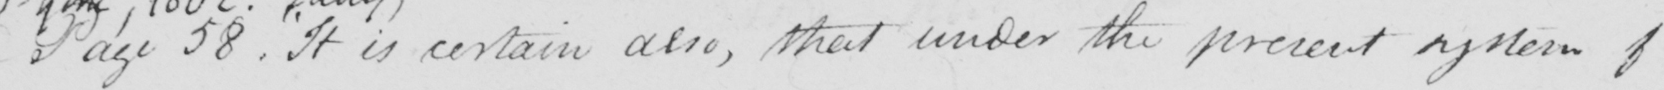Please transcribe the handwritten text in this image. Page 58 .  " It is certain also , that under the present system of 